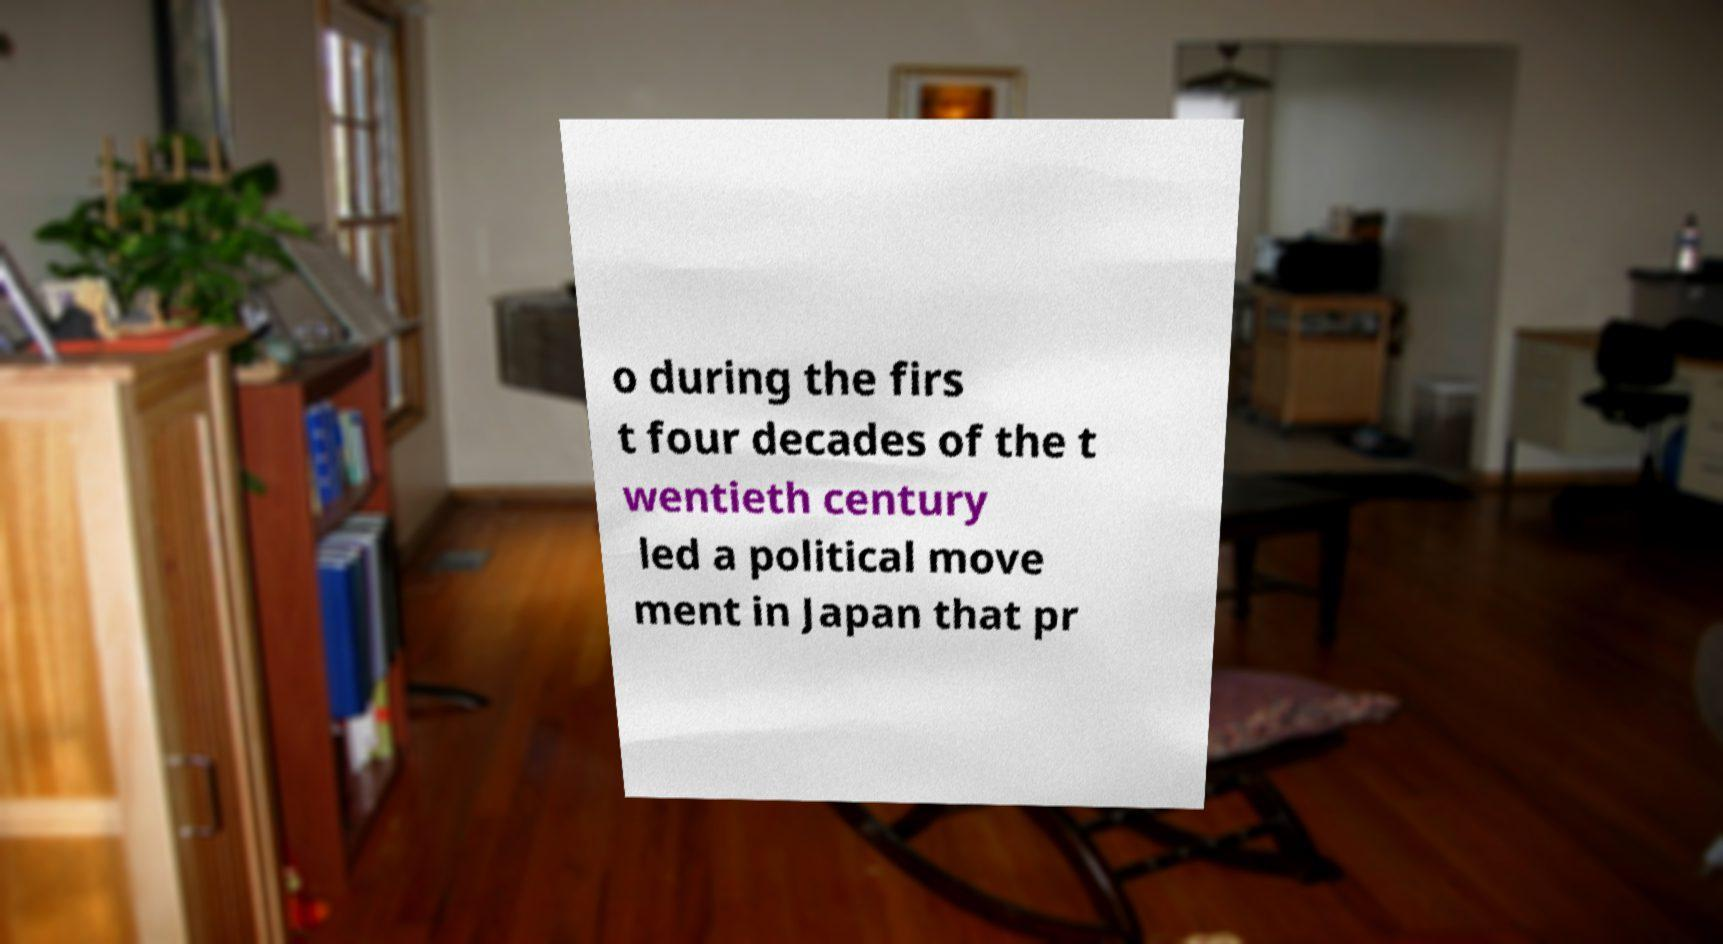Can you accurately transcribe the text from the provided image for me? o during the firs t four decades of the t wentieth century led a political move ment in Japan that pr 